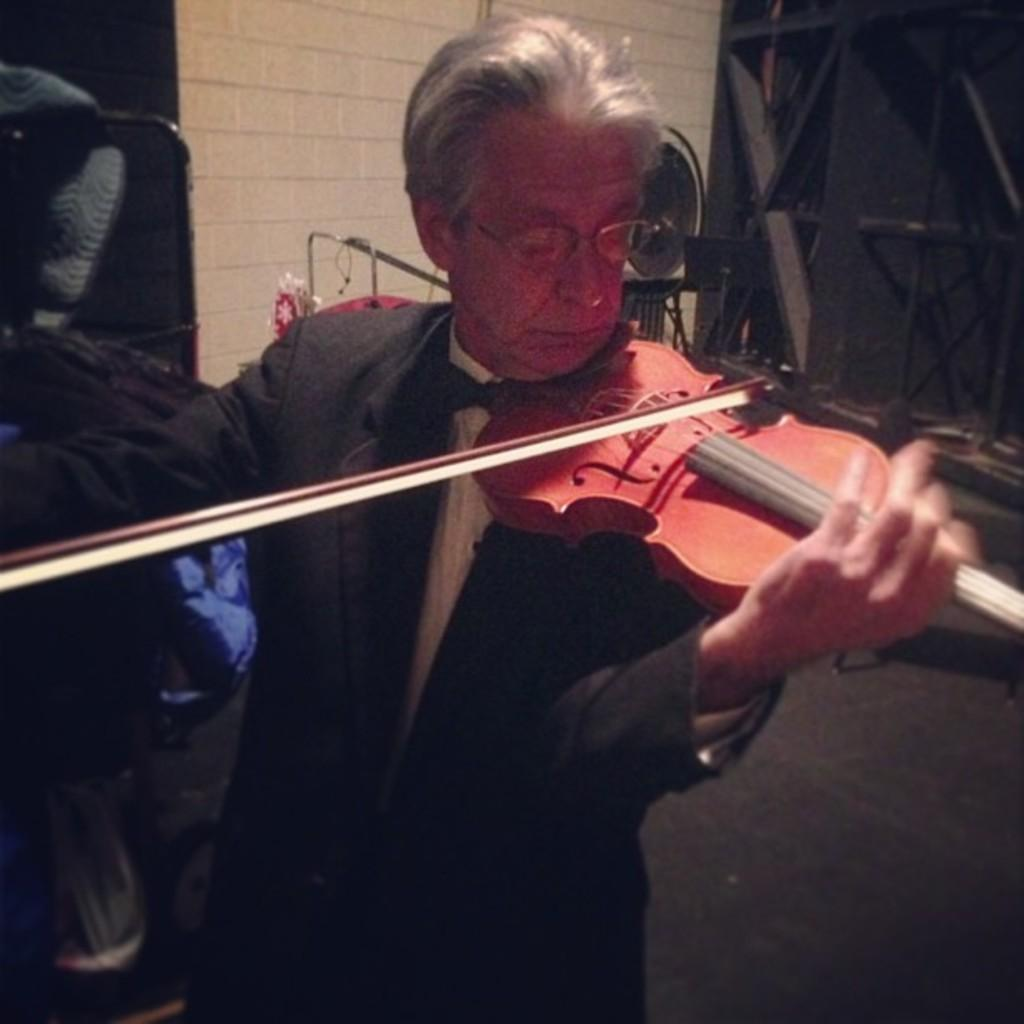What type of person is in the image? There is an old person in the image. What is the old person wearing? The old person is wearing a suit. What activity is the old person engaged in? The old person is playing a violin. What color is the violin? The violin is red in color. How many cacti are present on the farm in the image? There is no farm or cacti present in the image; it features an old person playing a red violin. 